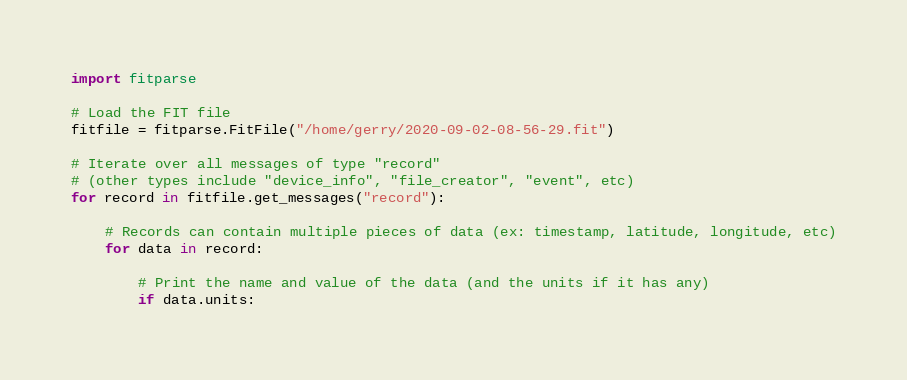<code> <loc_0><loc_0><loc_500><loc_500><_Python_>import fitparse

# Load the FIT file
fitfile = fitparse.FitFile("/home/gerry/2020-09-02-08-56-29.fit")

# Iterate over all messages of type "record"
# (other types include "device_info", "file_creator", "event", etc)
for record in fitfile.get_messages("record"):

    # Records can contain multiple pieces of data (ex: timestamp, latitude, longitude, etc)
    for data in record:

        # Print the name and value of the data (and the units if it has any)
        if data.units:</code> 